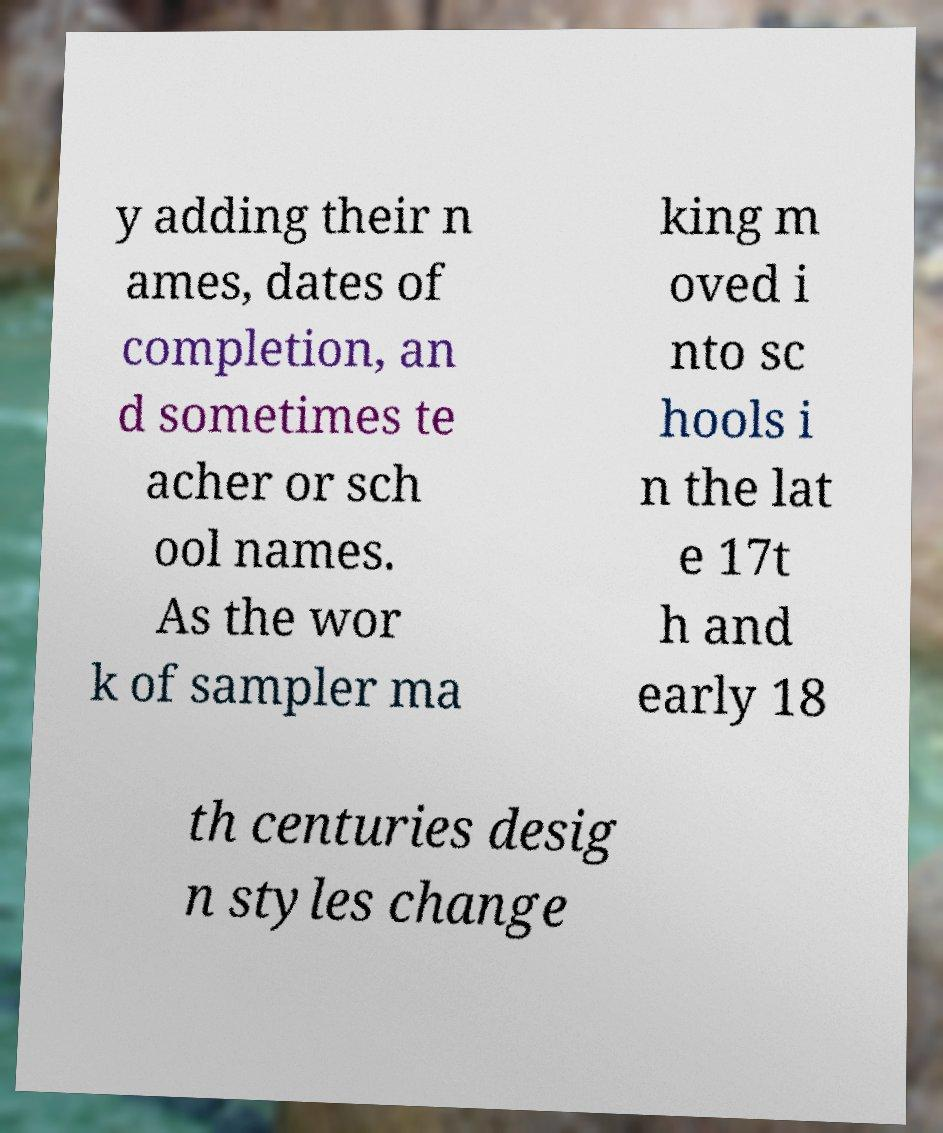Could you extract and type out the text from this image? y adding their n ames, dates of completion, an d sometimes te acher or sch ool names. As the wor k of sampler ma king m oved i nto sc hools i n the lat e 17t h and early 18 th centuries desig n styles change 